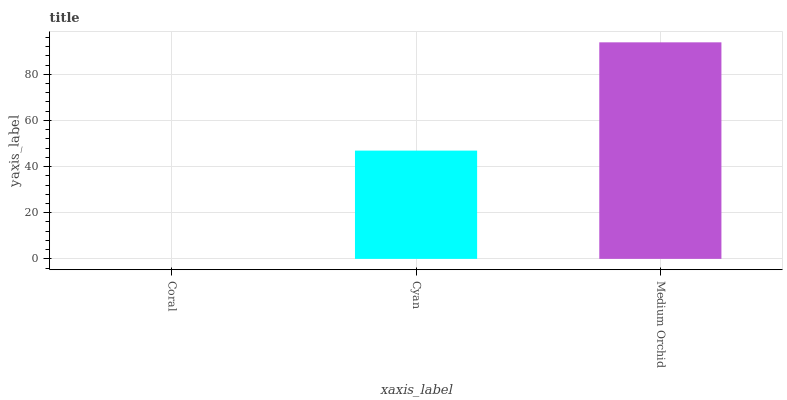Is Coral the minimum?
Answer yes or no. Yes. Is Medium Orchid the maximum?
Answer yes or no. Yes. Is Cyan the minimum?
Answer yes or no. No. Is Cyan the maximum?
Answer yes or no. No. Is Cyan greater than Coral?
Answer yes or no. Yes. Is Coral less than Cyan?
Answer yes or no. Yes. Is Coral greater than Cyan?
Answer yes or no. No. Is Cyan less than Coral?
Answer yes or no. No. Is Cyan the high median?
Answer yes or no. Yes. Is Cyan the low median?
Answer yes or no. Yes. Is Medium Orchid the high median?
Answer yes or no. No. Is Coral the low median?
Answer yes or no. No. 